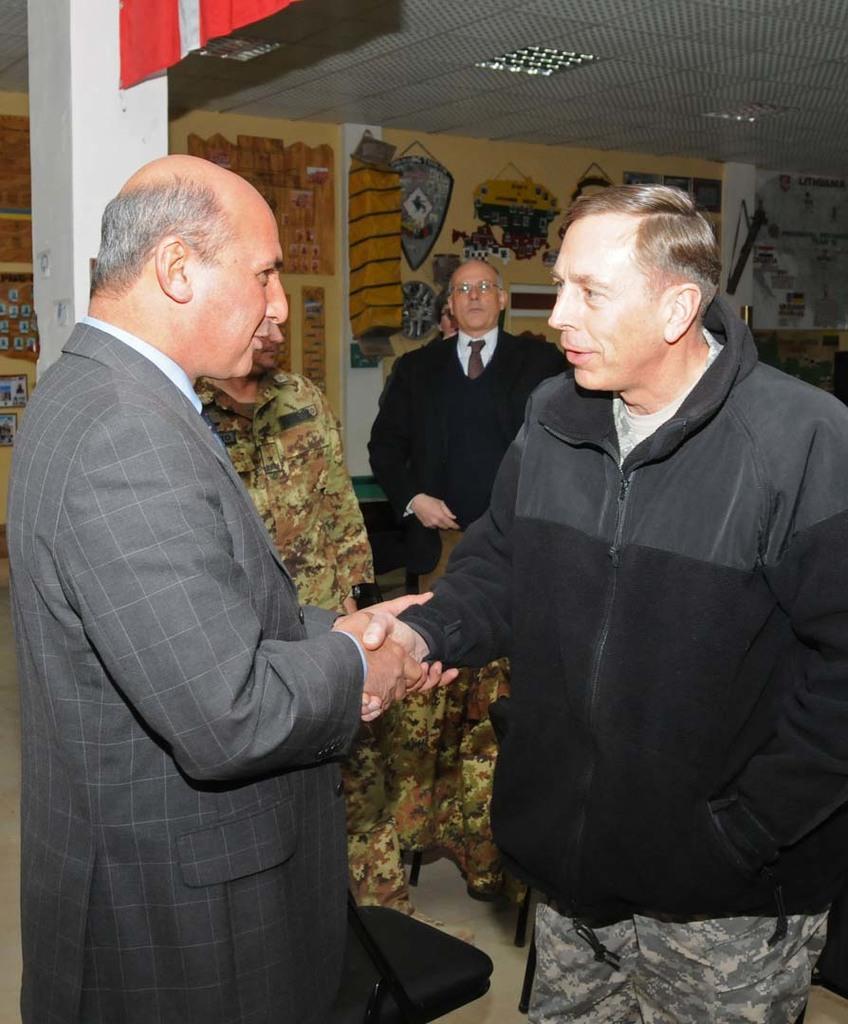Please provide a concise description of this image. In this picture there are two members shaking their hands. Both of them were men. In the background there is a person standing, wearing spectacles. We can observe a wall in the background with some charts stuck on it. There is a white color pillar on the left side. 